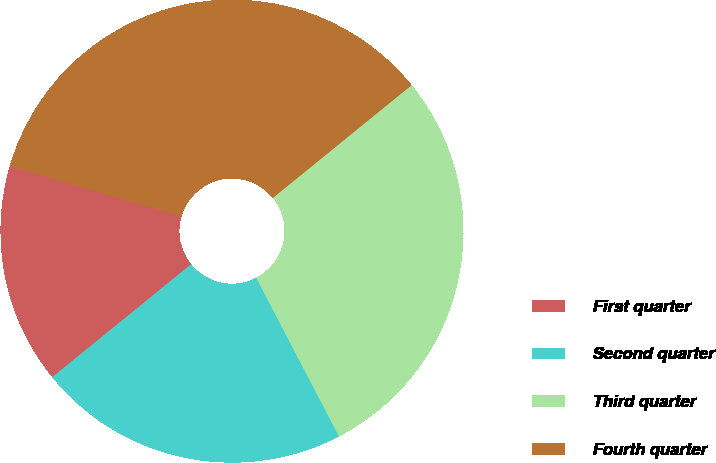Convert chart to OTSL. <chart><loc_0><loc_0><loc_500><loc_500><pie_chart><fcel>First quarter<fcel>Second quarter<fcel>Third quarter<fcel>Fourth quarter<nl><fcel>15.38%<fcel>21.79%<fcel>28.21%<fcel>34.62%<nl></chart> 